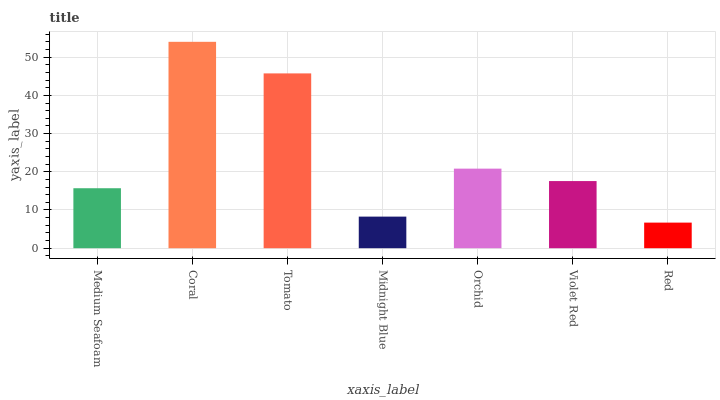Is Red the minimum?
Answer yes or no. Yes. Is Coral the maximum?
Answer yes or no. Yes. Is Tomato the minimum?
Answer yes or no. No. Is Tomato the maximum?
Answer yes or no. No. Is Coral greater than Tomato?
Answer yes or no. Yes. Is Tomato less than Coral?
Answer yes or no. Yes. Is Tomato greater than Coral?
Answer yes or no. No. Is Coral less than Tomato?
Answer yes or no. No. Is Violet Red the high median?
Answer yes or no. Yes. Is Violet Red the low median?
Answer yes or no. Yes. Is Medium Seafoam the high median?
Answer yes or no. No. Is Medium Seafoam the low median?
Answer yes or no. No. 